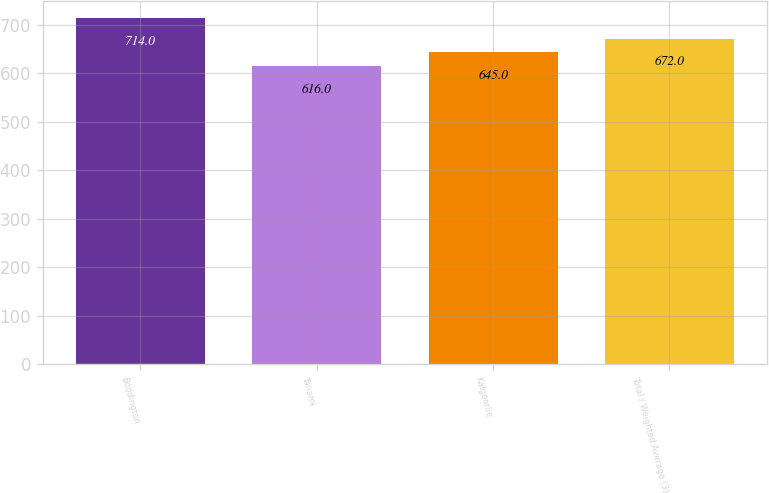Convert chart. <chart><loc_0><loc_0><loc_500><loc_500><bar_chart><fcel>Boddington<fcel>Tanami<fcel>Kalgoorlie<fcel>Total / Weighted Average (3)<nl><fcel>714<fcel>616<fcel>645<fcel>672<nl></chart> 